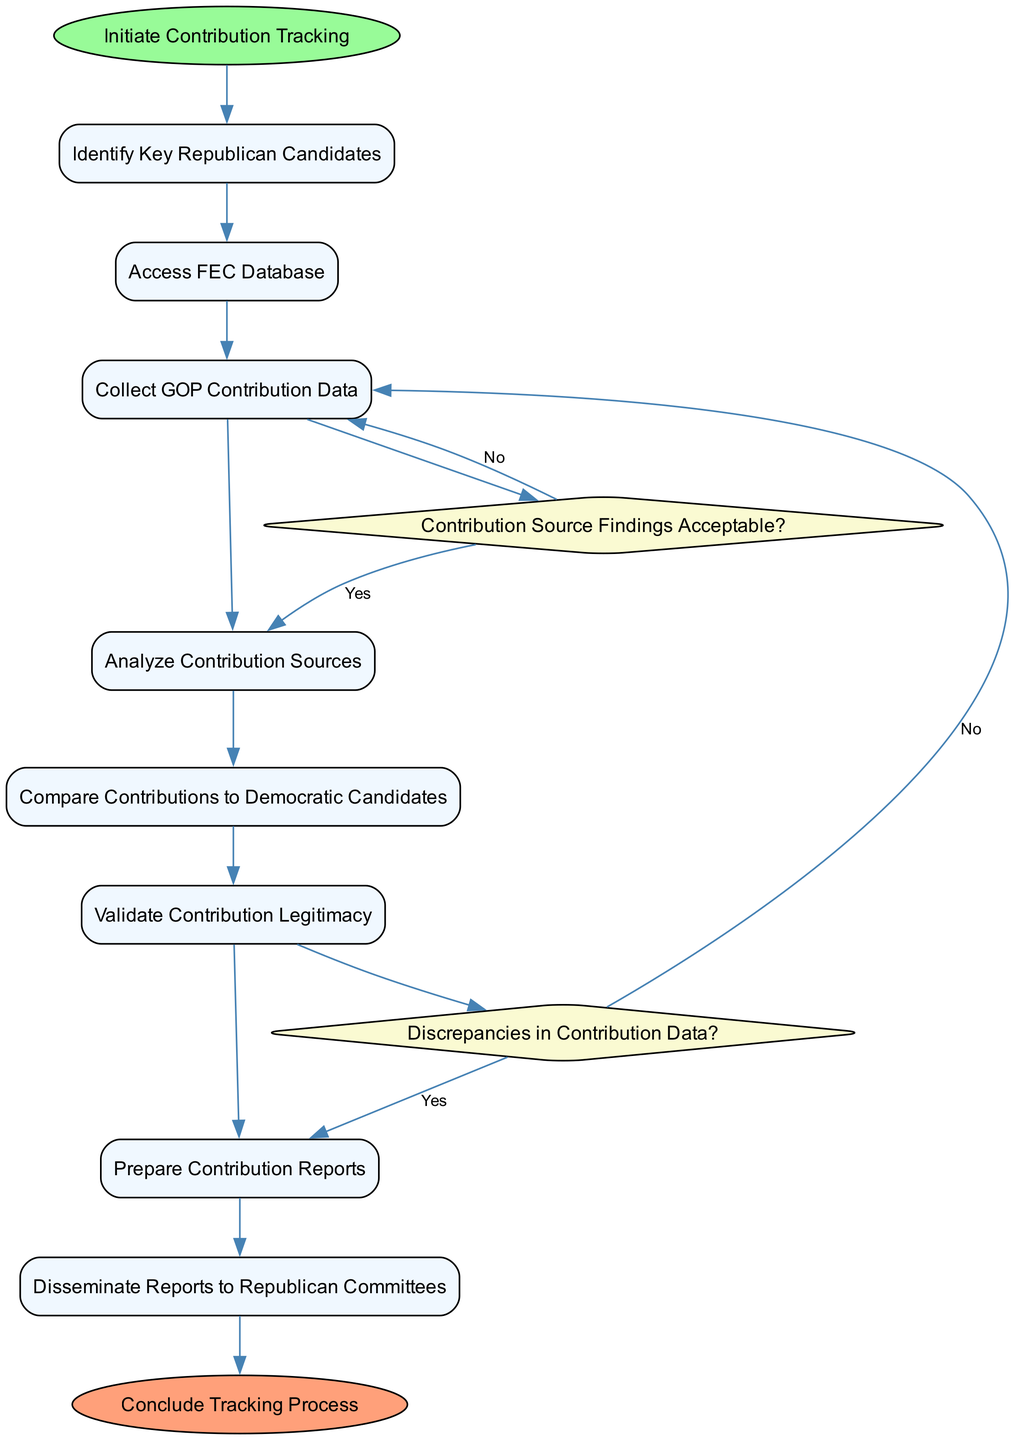What is the starting event in the diagram? The start event in the diagram is labeled as "Initiate Contribution Tracking." This is identified first in the flow of the activity diagram as it is the initial action that kicks off the process.
Answer: Initiate Contribution Tracking How many activities are listed in the diagram? The diagram contains a total of eight activities related to tracking campaign contributions. Each activity is defined in the activities section of the data provided.
Answer: 8 What action follows the "Access FEC Database" activity? The activity that follows "Access FEC Database" is "Collect GOP Contribution Data." To identify this, we look at the sequential order of activities in the diagram.
Answer: Collect GOP Contribution Data What is the decision point labeled as in the diagram? There are two decision points in the diagram: "Contribution Source Findings Acceptable?" and "Discrepancies in Contribution Data?" Each one represents a condition that must be evaluated during the tracking process.
Answer: Contribution Source Findings Acceptable?, Discrepancies in Contribution Data? If the answer to the decision "Contribution Source Findings Acceptable?" is "No", which activity is the next step? If the answer to this decision point is "No," the next step would be to return to the "Collect GOP Contribution Data" activity. This is shown in the flow of the diagram where a decision leads back to a previous activity based on the evaluation.
Answer: Collect GOP Contribution Data What is the final event in the diagram? The final event in the diagram is "Conclude Tracking Process." This is noted as the last step completed once all activities and decisions have been processed and analyzed.
Answer: Conclude Tracking Process Which activity involves assessing donor demographics? The activity responsible for assessing donor demographics is "Analyze Contribution Sources." This activity specifically looks into the origins and characteristics of the contributions received.
Answer: Analyze Contribution Sources What relationships exist between the last activity and the end event? The last activity in the diagram, "Disseminate Reports to Republican Committees," has a direct edge leading to the end event "Conclude Tracking Process." This indicates that after reporting, the process is completed.
Answer: Direct edge leading to the end event What would happen if significant discrepancies were found in the contribution data? If significant discrepancies are found in the contribution data, it would redirect the process back to "Collect GOP Contribution Data" for reevaluation. This follows from the decision point in the workflow that addresses discrepancies.
Answer: Redirect to Collect GOP Contribution Data 